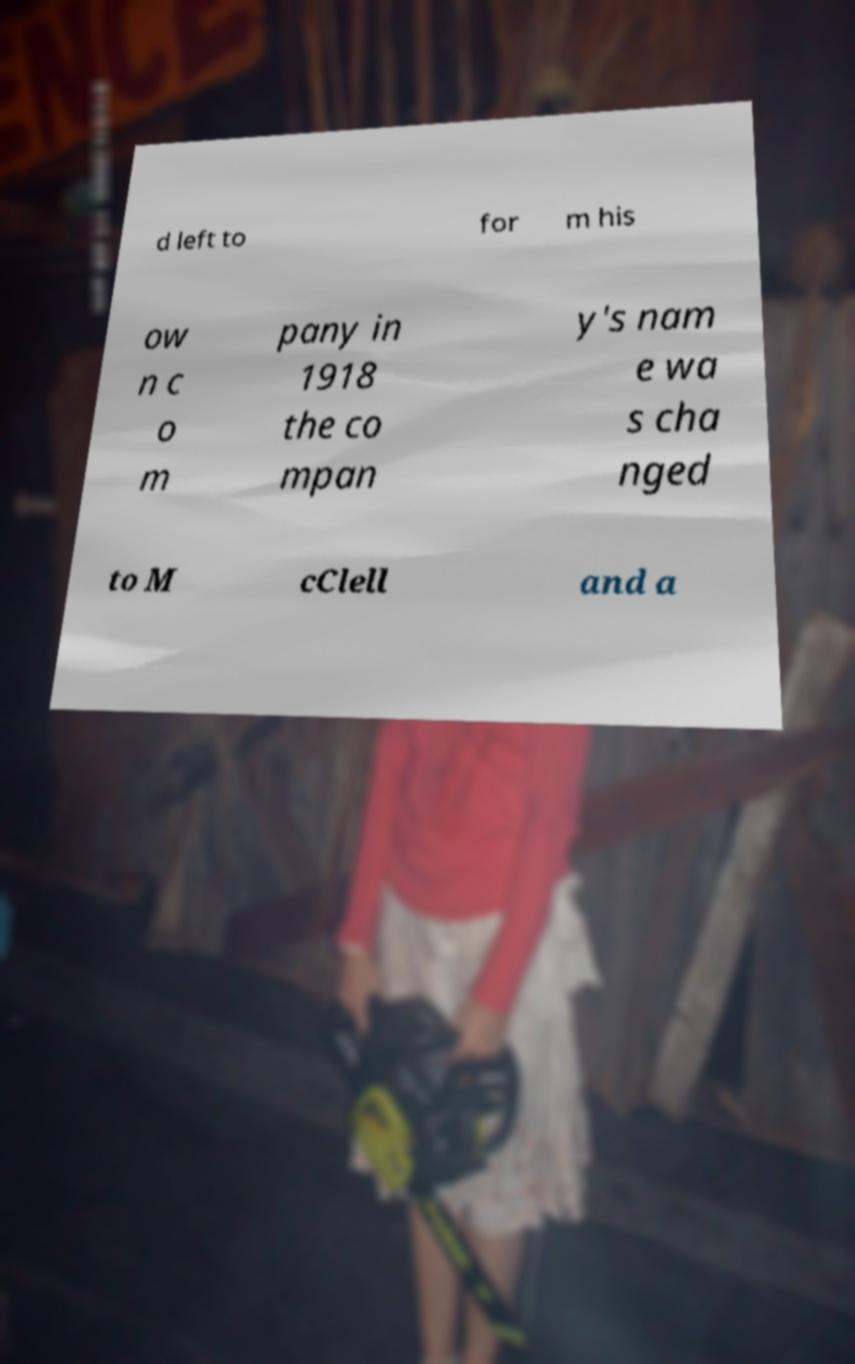For documentation purposes, I need the text within this image transcribed. Could you provide that? d left to for m his ow n c o m pany in 1918 the co mpan y's nam e wa s cha nged to M cClell and a 